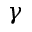<formula> <loc_0><loc_0><loc_500><loc_500>\gamma</formula> 